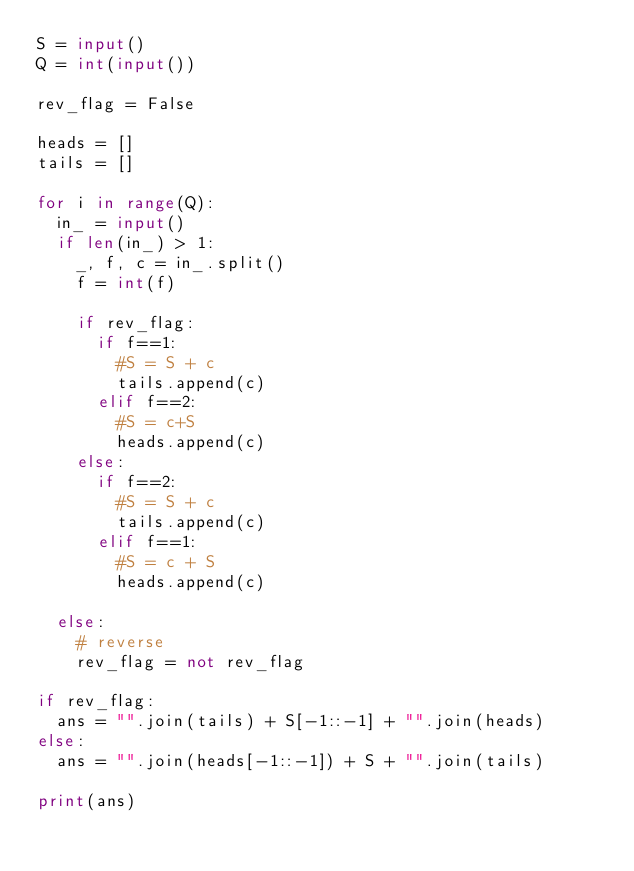Convert code to text. <code><loc_0><loc_0><loc_500><loc_500><_Python_>S = input()
Q = int(input())

rev_flag = False

heads = []
tails = []

for i in range(Q):
  in_ = input()
  if len(in_) > 1:
    _, f, c = in_.split()
    f = int(f)
    
    if rev_flag:
      if f==1:
        #S = S + c
        tails.append(c)
      elif f==2:
        #S = c+S
        heads.append(c)
    else:
      if f==2:
        #S = S + c
        tails.append(c)
      elif f==1:
        #S = c + S
        heads.append(c)
    
  else:
    # reverse    
    rev_flag = not rev_flag

if rev_flag:
  ans = "".join(tails) + S[-1::-1] + "".join(heads)
else:
  ans = "".join(heads[-1::-1]) + S + "".join(tails)

print(ans)
    
  </code> 